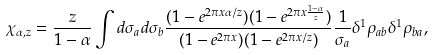Convert formula to latex. <formula><loc_0><loc_0><loc_500><loc_500>\chi _ { \alpha , z } = \frac { z } { 1 - \alpha } \int d \sigma _ { a } d \sigma _ { b } \frac { ( 1 - e ^ { 2 \pi x \alpha / z } ) ( 1 - e ^ { 2 \pi x \frac { 1 - \alpha } { z } } ) } { ( 1 - e ^ { 2 \pi x } ) ( 1 - e ^ { 2 \pi x / z } ) } \frac { 1 } { \sigma _ { a } } \delta ^ { 1 } \rho _ { a b } \delta ^ { 1 } \rho _ { b a } ,</formula> 